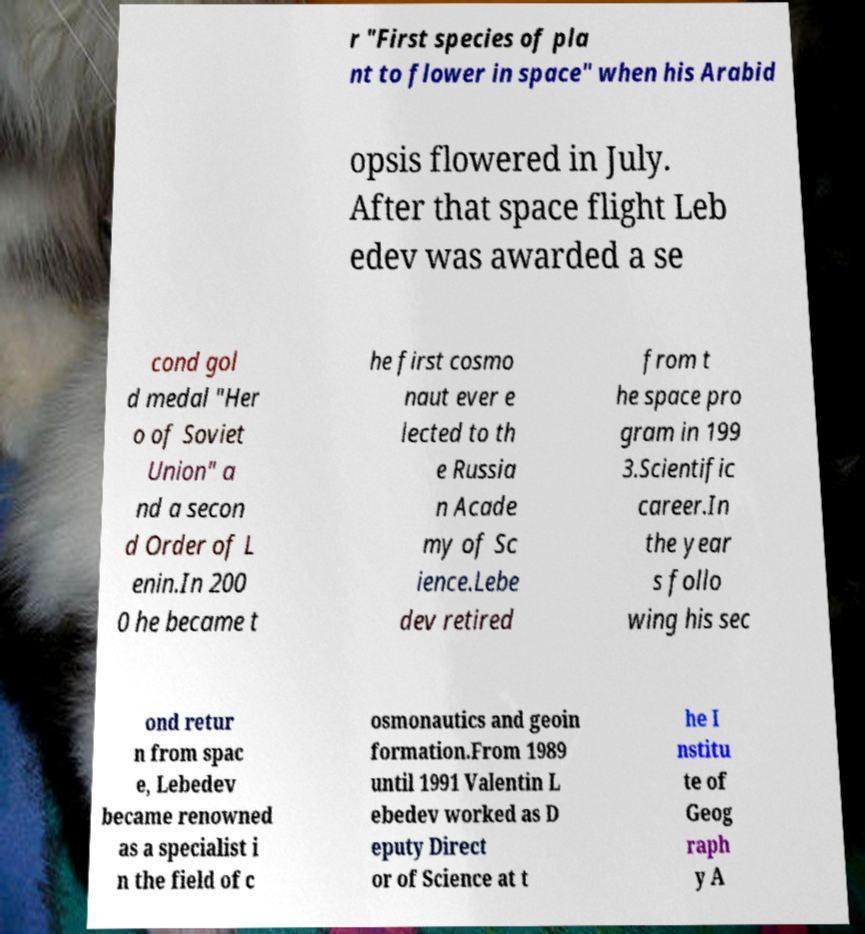What messages or text are displayed in this image? I need them in a readable, typed format. r "First species of pla nt to flower in space" when his Arabid opsis flowered in July. After that space flight Leb edev was awarded a se cond gol d medal "Her o of Soviet Union" a nd a secon d Order of L enin.In 200 0 he became t he first cosmo naut ever e lected to th e Russia n Acade my of Sc ience.Lebe dev retired from t he space pro gram in 199 3.Scientific career.In the year s follo wing his sec ond retur n from spac e, Lebedev became renowned as a specialist i n the field of c osmonautics and geoin formation.From 1989 until 1991 Valentin L ebedev worked as D eputy Direct or of Science at t he I nstitu te of Geog raph y A 